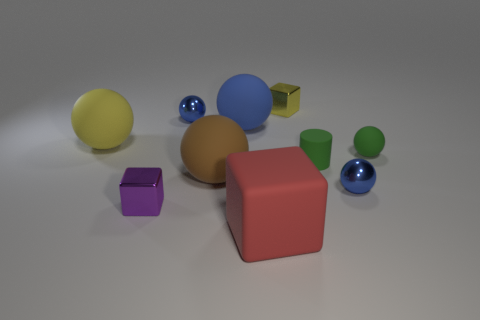Subtract all tiny rubber spheres. How many spheres are left? 5 Subtract all cyan cylinders. How many blue spheres are left? 3 Subtract all green balls. How many balls are left? 5 Subtract 3 spheres. How many spheres are left? 3 Subtract all purple spheres. Subtract all cyan cylinders. How many spheres are left? 6 Subtract all balls. How many objects are left? 4 Subtract 0 blue cylinders. How many objects are left? 10 Subtract all large rubber things. Subtract all red rubber things. How many objects are left? 5 Add 4 big yellow matte spheres. How many big yellow matte spheres are left? 5 Add 5 large red rubber blocks. How many large red rubber blocks exist? 6 